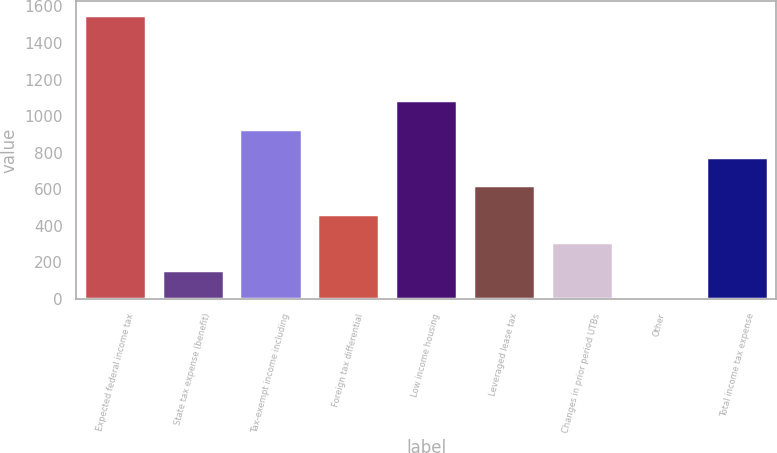Convert chart to OTSL. <chart><loc_0><loc_0><loc_500><loc_500><bar_chart><fcel>Expected federal income tax<fcel>State tax expense (benefit)<fcel>Tax-exempt income including<fcel>Foreign tax differential<fcel>Low income housing<fcel>Leveraged lease tax<fcel>Changes in prior period UTBs<fcel>Other<fcel>Total income tax expense<nl><fcel>1550<fcel>157.7<fcel>931.2<fcel>467.1<fcel>1085.9<fcel>621.8<fcel>312.4<fcel>3<fcel>776.5<nl></chart> 